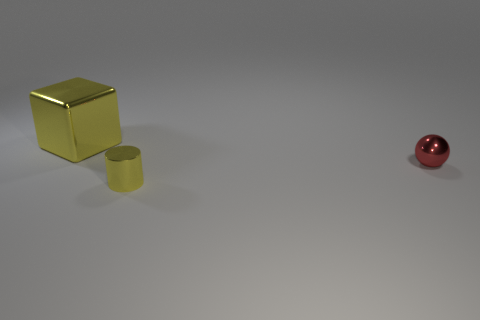Is the number of tiny green rubber spheres less than the number of small red metallic balls?
Provide a succinct answer. Yes. How many red things have the same material as the sphere?
Make the answer very short. 0. There is a cylinder that is the same material as the large yellow cube; what is its color?
Offer a terse response. Yellow. The small red metal thing has what shape?
Keep it short and to the point. Sphere. What number of cylinders have the same color as the tiny shiny ball?
Offer a very short reply. 0. What shape is the thing that is the same size as the cylinder?
Provide a short and direct response. Sphere. Is there a block that has the same size as the ball?
Ensure brevity in your answer.  No. There is a object that is the same size as the cylinder; what is its material?
Ensure brevity in your answer.  Metal. What is the size of the thing that is left of the yellow object that is to the right of the large metallic block?
Provide a short and direct response. Large. There is a yellow shiny object in front of the ball; is it the same size as the tiny red metallic ball?
Provide a short and direct response. Yes. 